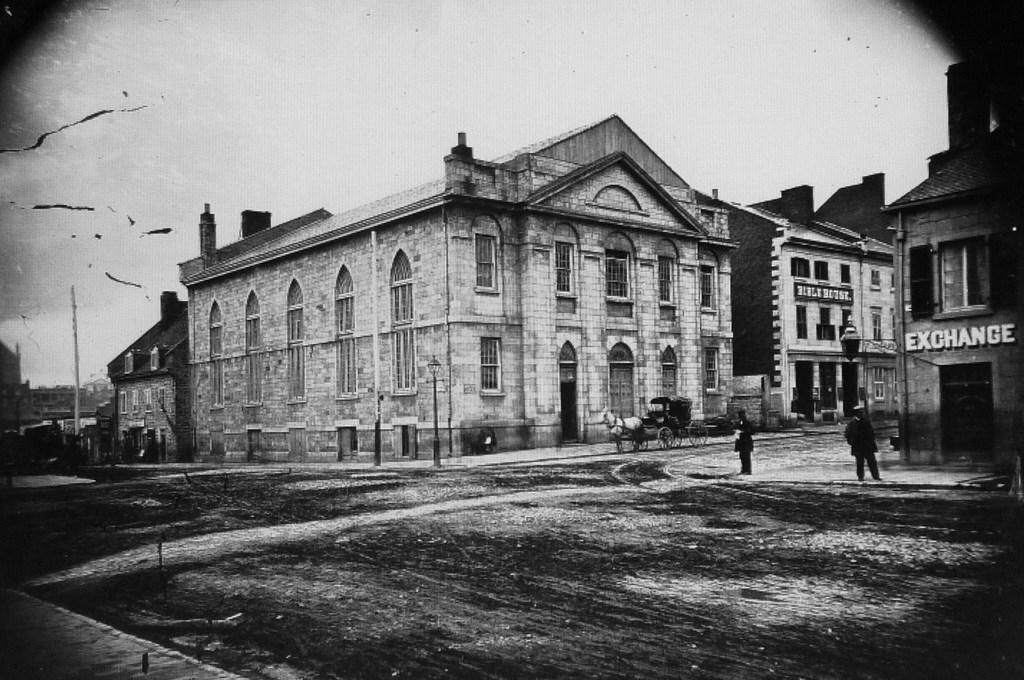Could you give a brief overview of what you see in this image? This is a black and white image and here we can see buildings, poles and some vehicles and people. At the bottom, there is road. 